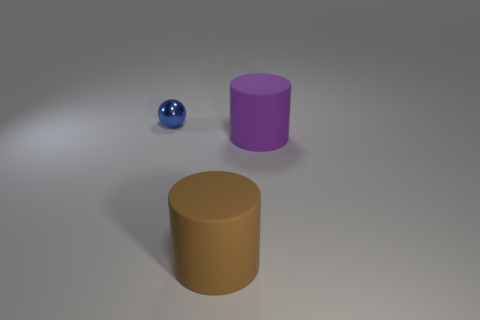Subtract all purple cylinders. How many cylinders are left? 1 Add 1 cyan shiny cylinders. How many objects exist? 4 Subtract all cylinders. How many objects are left? 1 Subtract all tiny purple rubber objects. Subtract all tiny metallic things. How many objects are left? 2 Add 1 brown rubber things. How many brown rubber things are left? 2 Add 3 blue spheres. How many blue spheres exist? 4 Subtract 1 brown cylinders. How many objects are left? 2 Subtract all green spheres. Subtract all brown cylinders. How many spheres are left? 1 